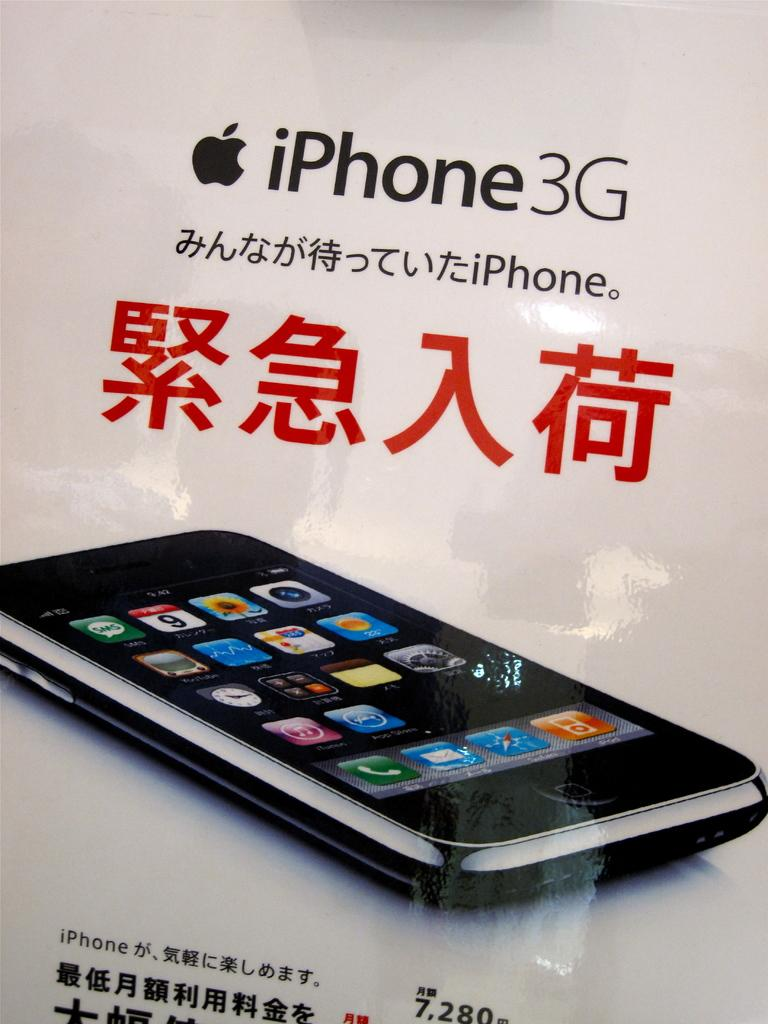<image>
Give a short and clear explanation of the subsequent image. An iphone 3g box graphic with chinese symbols written in red 